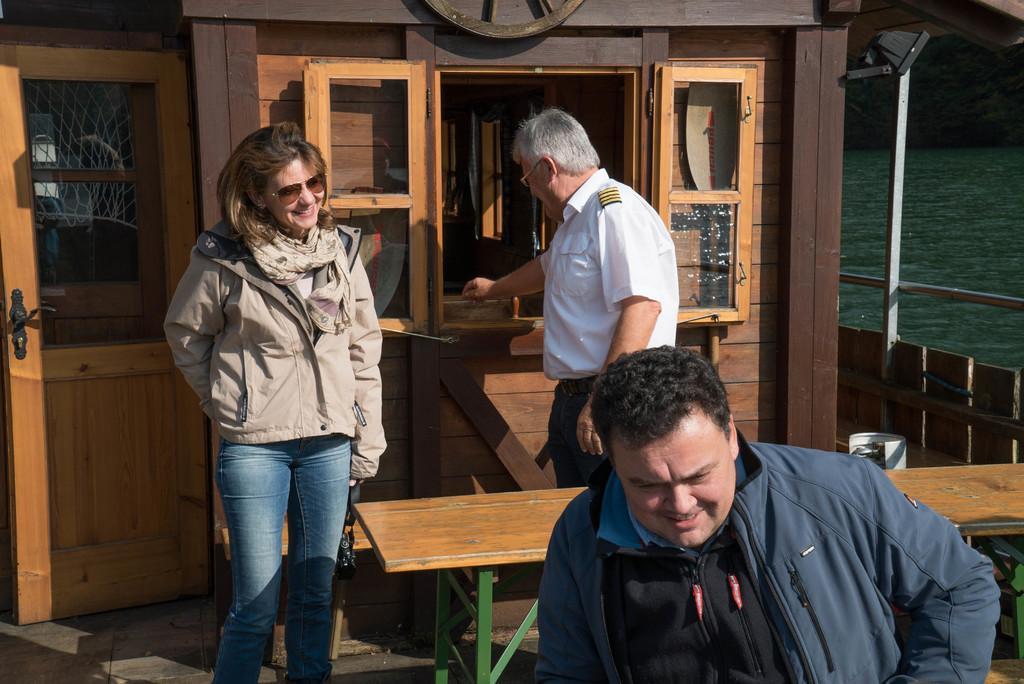Can you describe this image briefly? In this image, on the right side, we can see a man wearing a blue color jacket. On the right side, we can also see the white color shirt is standing in front of the table. On the left side, we can see a woman, on the left side, we can also see a door which is closed. At the door, we can see a net fence. On the right side, we can see a water in an ocean. 